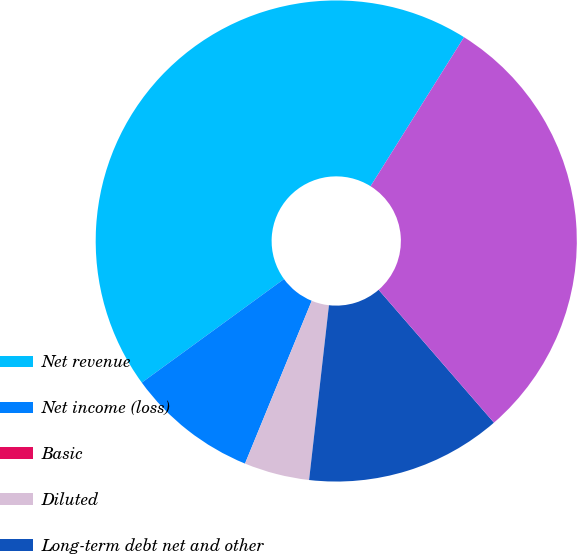<chart> <loc_0><loc_0><loc_500><loc_500><pie_chart><fcel>Net revenue<fcel>Net income (loss)<fcel>Basic<fcel>Diluted<fcel>Long-term debt net and other<fcel>Total assets (9)<nl><fcel>43.93%<fcel>8.79%<fcel>0.0%<fcel>4.39%<fcel>13.18%<fcel>29.71%<nl></chart> 